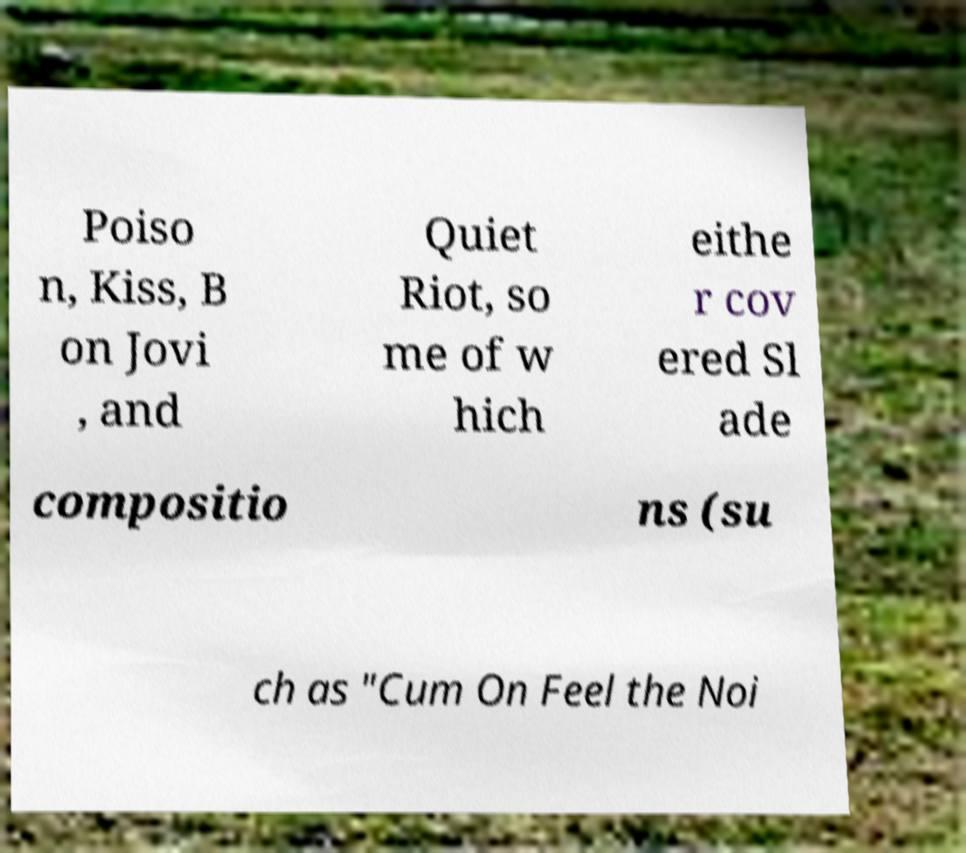Please identify and transcribe the text found in this image. Poiso n, Kiss, B on Jovi , and Quiet Riot, so me of w hich eithe r cov ered Sl ade compositio ns (su ch as "Cum On Feel the Noi 